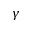<formula> <loc_0><loc_0><loc_500><loc_500>\gamma</formula> 